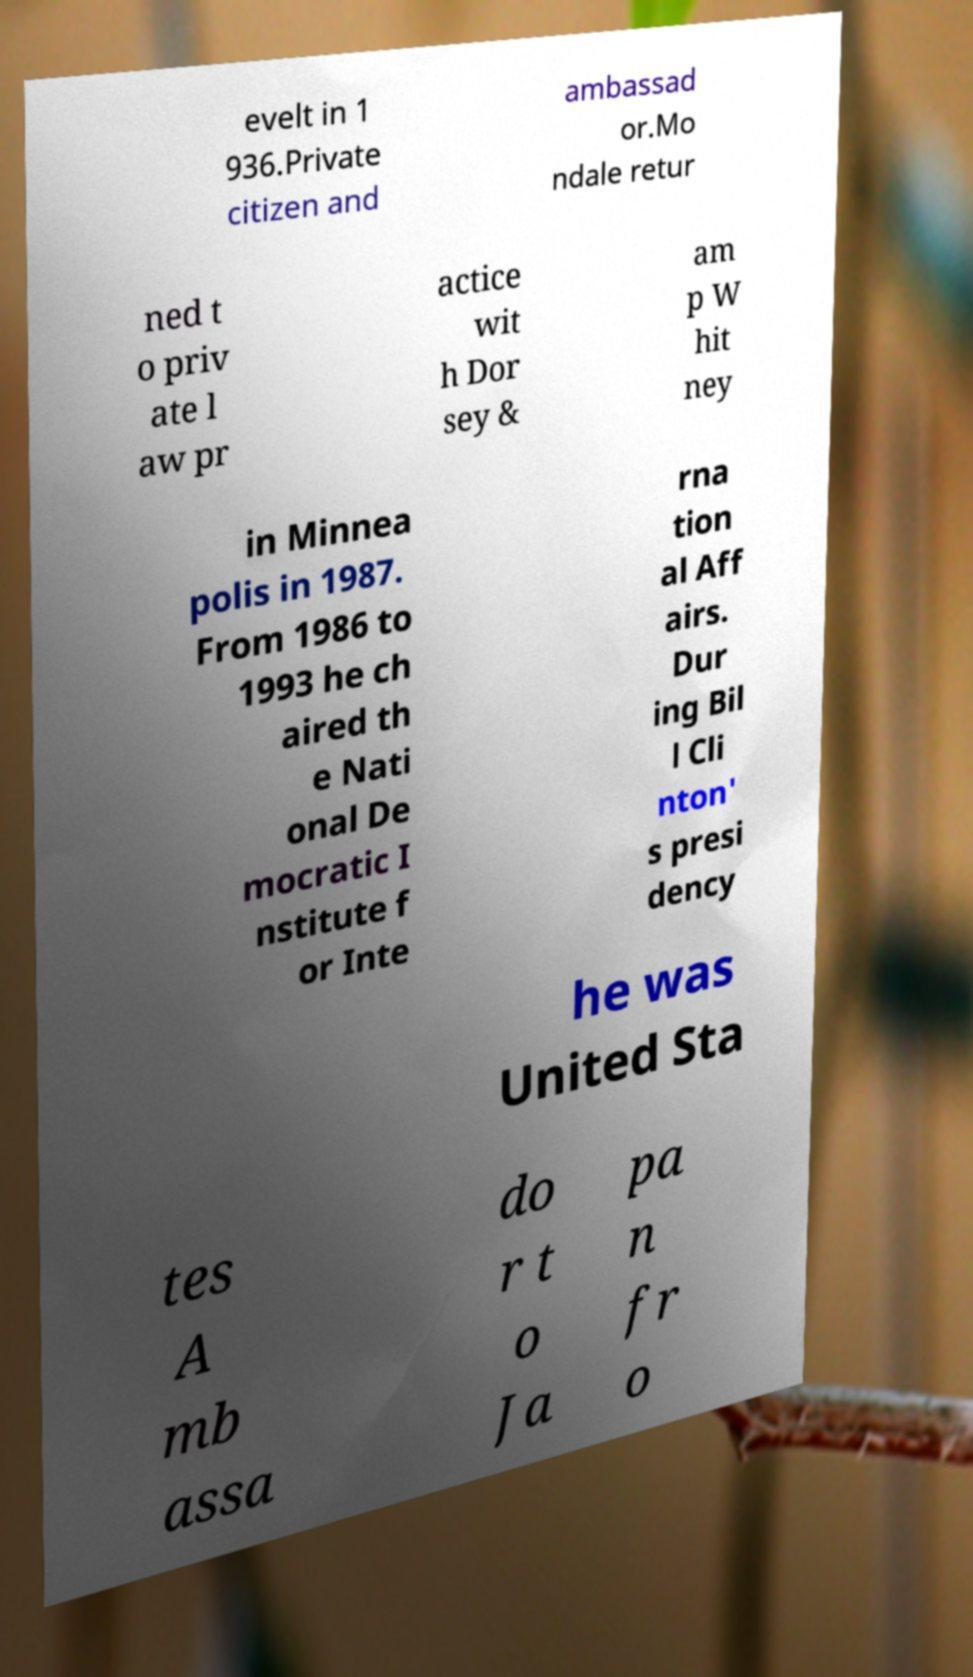I need the written content from this picture converted into text. Can you do that? evelt in 1 936.Private citizen and ambassad or.Mo ndale retur ned t o priv ate l aw pr actice wit h Dor sey & am p W hit ney in Minnea polis in 1987. From 1986 to 1993 he ch aired th e Nati onal De mocratic I nstitute f or Inte rna tion al Aff airs. Dur ing Bil l Cli nton' s presi dency he was United Sta tes A mb assa do r t o Ja pa n fr o 